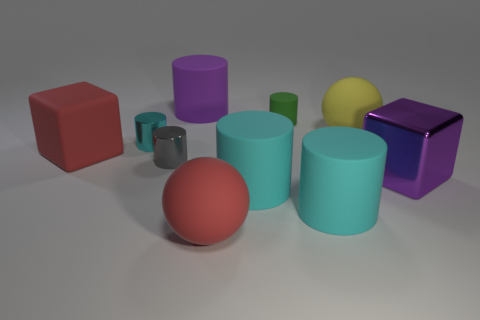Subtract all yellow blocks. How many cyan cylinders are left? 3 Subtract 2 cylinders. How many cylinders are left? 4 Subtract all gray cylinders. How many cylinders are left? 5 Subtract all big purple matte cylinders. How many cylinders are left? 5 Subtract all purple cylinders. Subtract all yellow balls. How many cylinders are left? 5 Subtract all cylinders. How many objects are left? 4 Add 1 large shiny objects. How many large shiny objects exist? 2 Subtract 2 cyan cylinders. How many objects are left? 8 Subtract all yellow things. Subtract all large red balls. How many objects are left? 8 Add 7 big red rubber objects. How many big red rubber objects are left? 9 